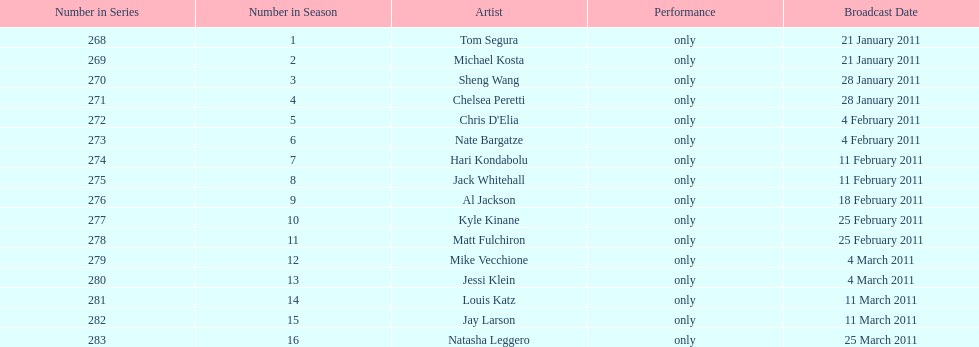Which month had the most air dates? February. 